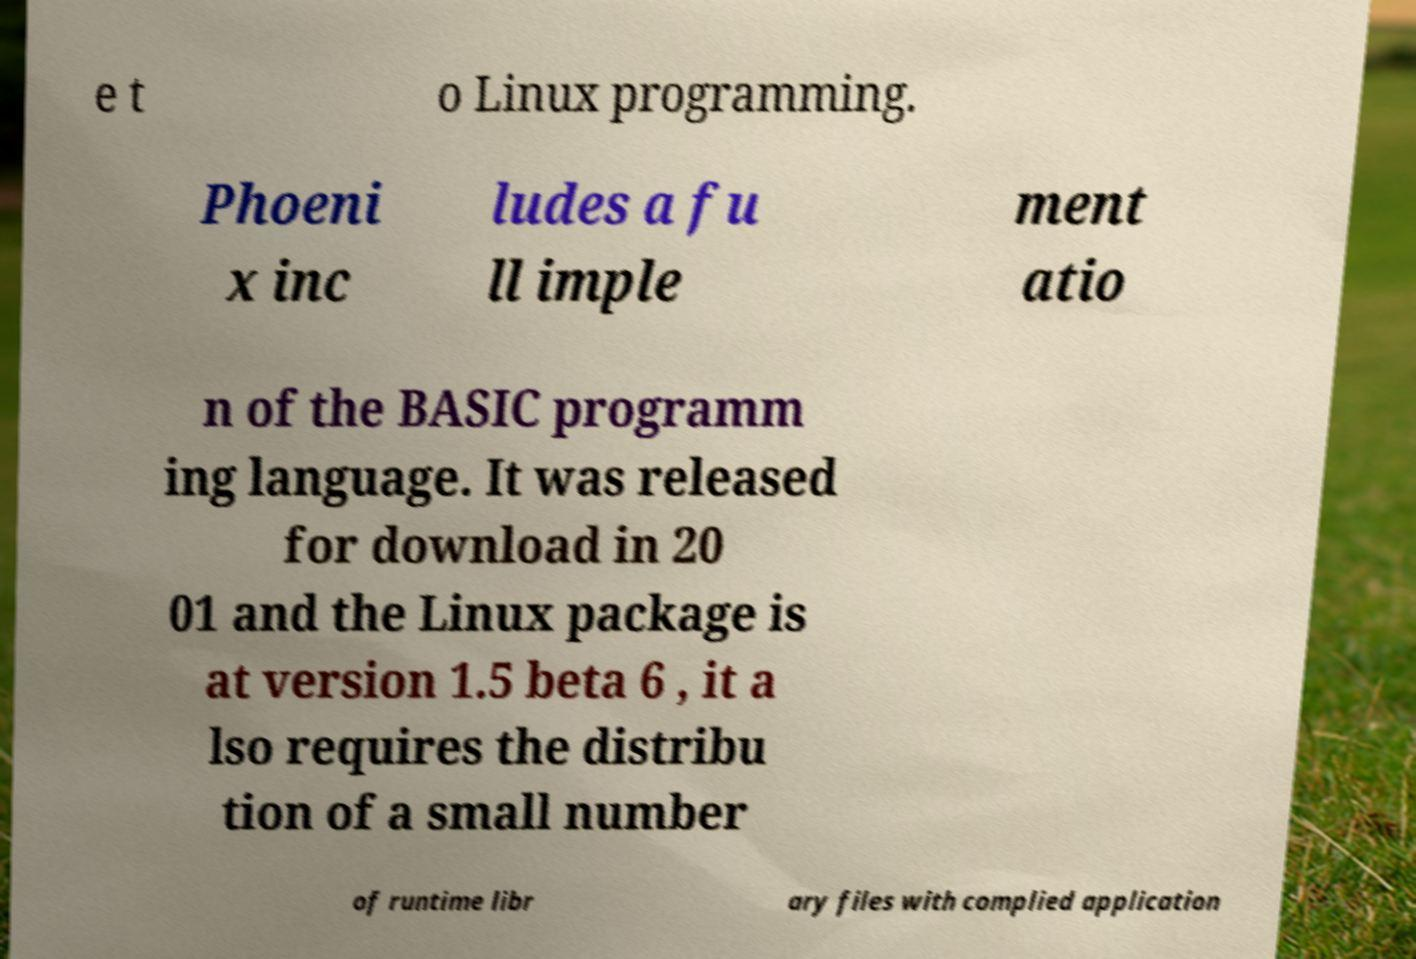Please identify and transcribe the text found in this image. e t o Linux programming. Phoeni x inc ludes a fu ll imple ment atio n of the BASIC programm ing language. It was released for download in 20 01 and the Linux package is at version 1.5 beta 6 , it a lso requires the distribu tion of a small number of runtime libr ary files with complied application 